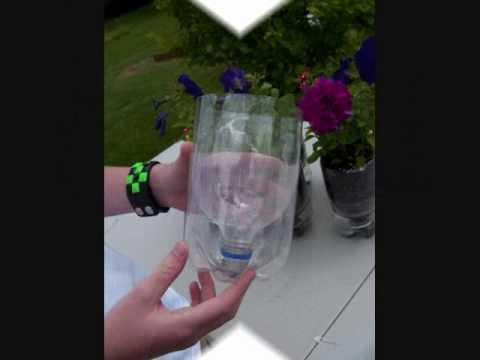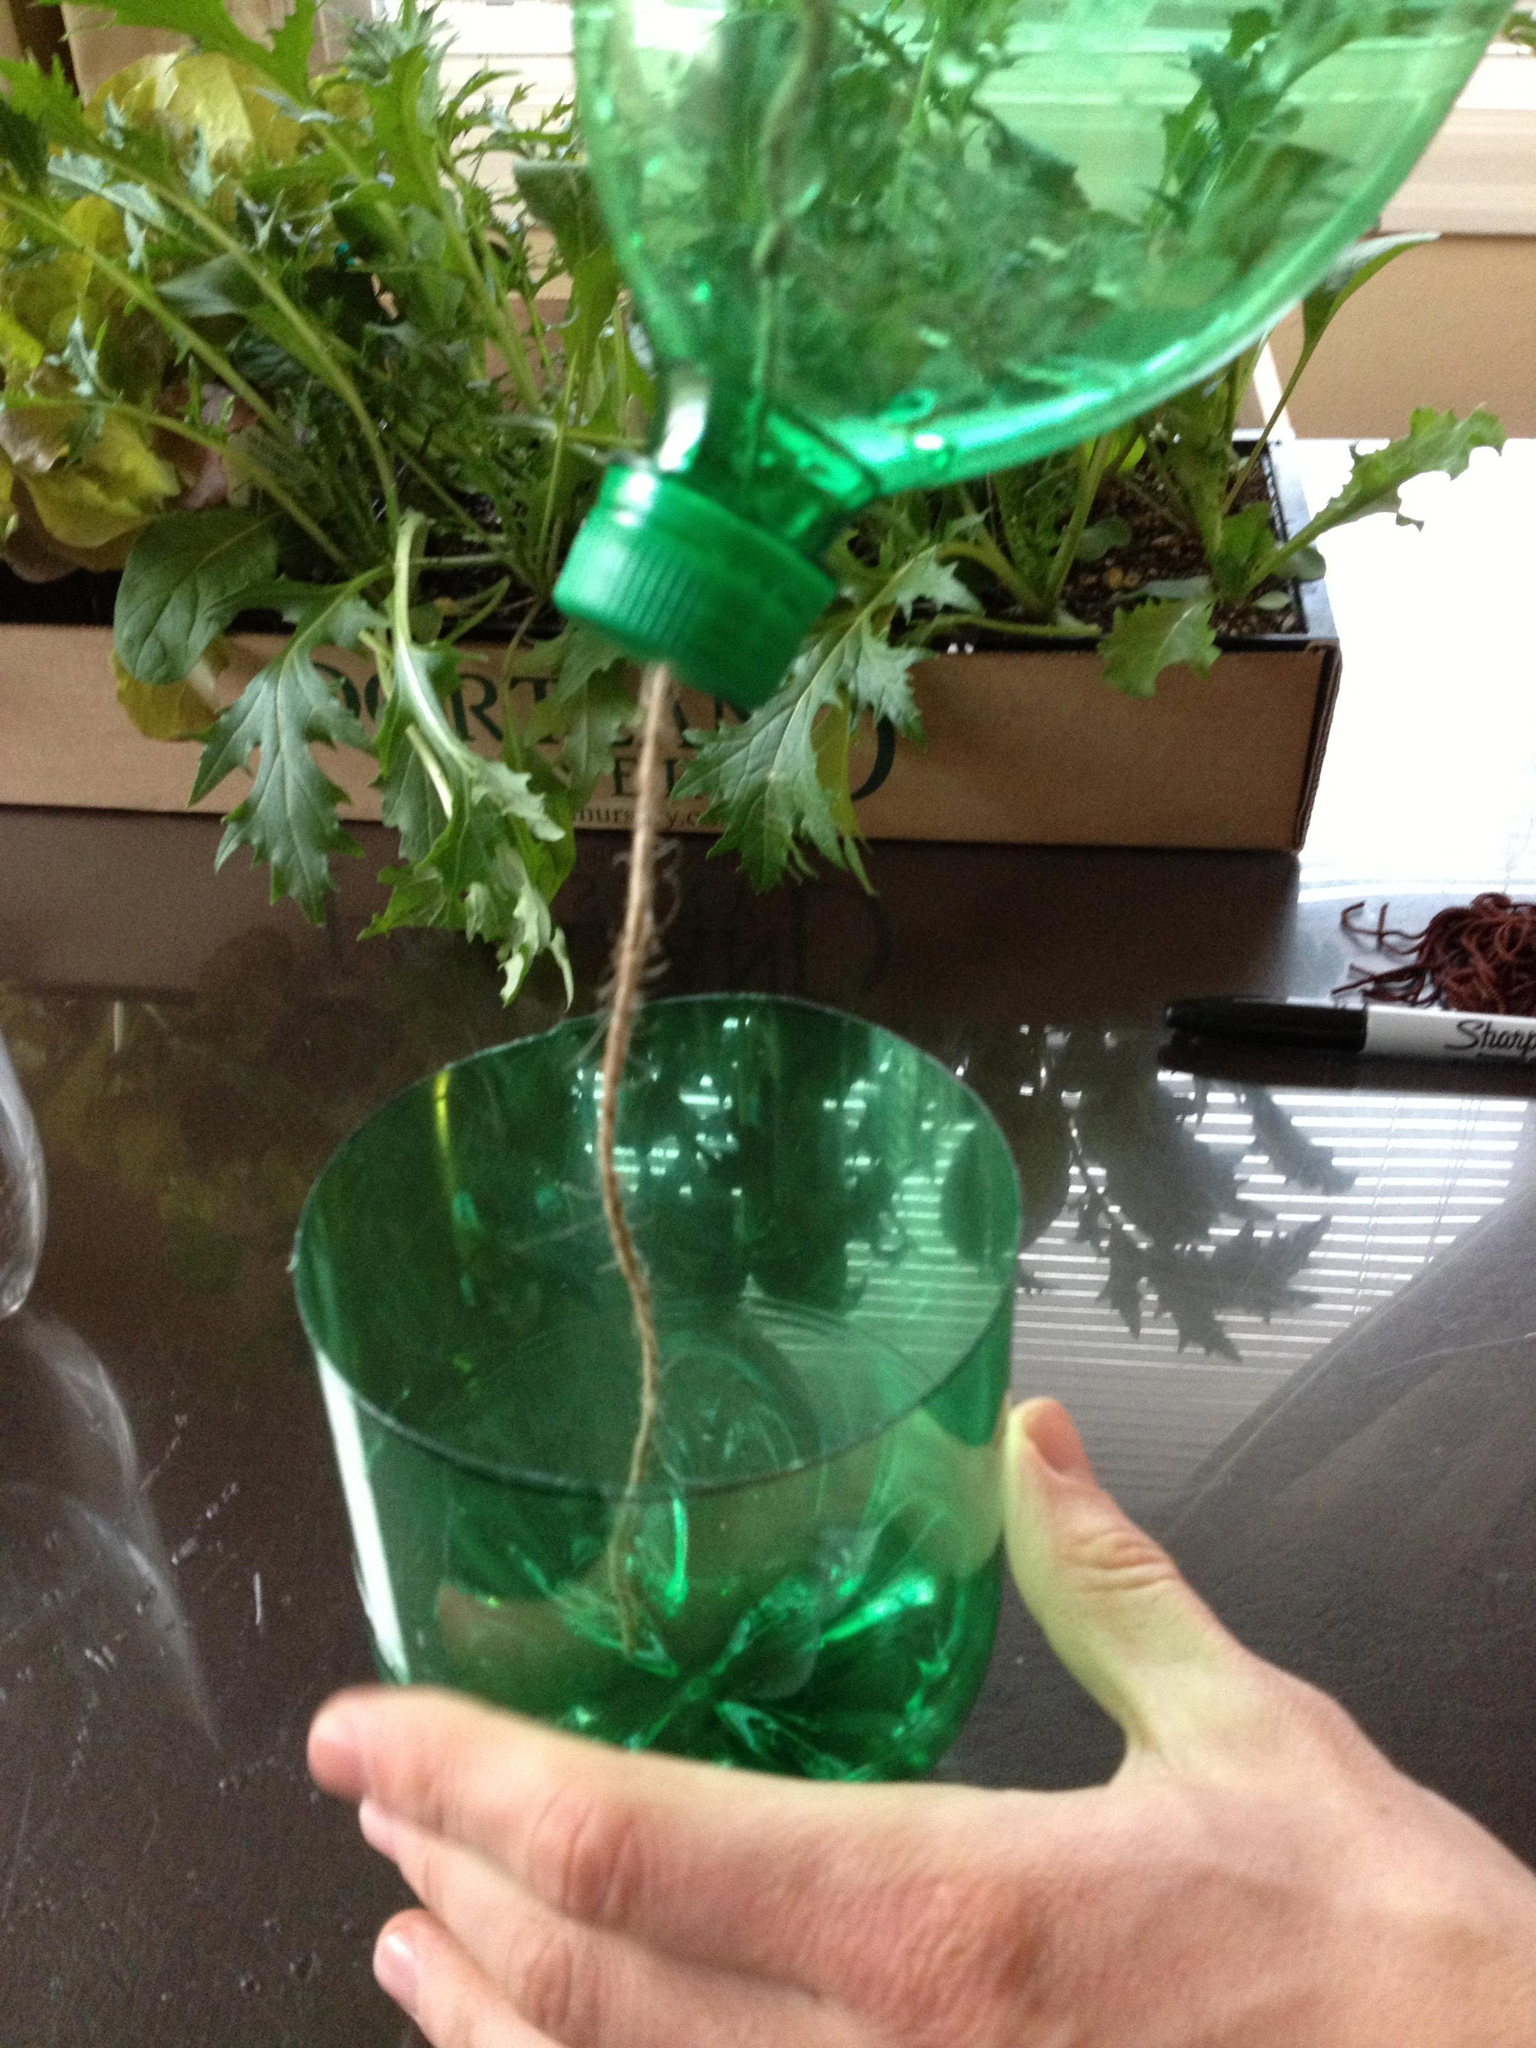The first image is the image on the left, the second image is the image on the right. For the images shown, is this caption "At least one plastic bottle has been cut in half." true? Answer yes or no. Yes. The first image is the image on the left, the second image is the image on the right. Considering the images on both sides, is "Human hands are visible holding soda bottles in at least one image." valid? Answer yes or no. Yes. 